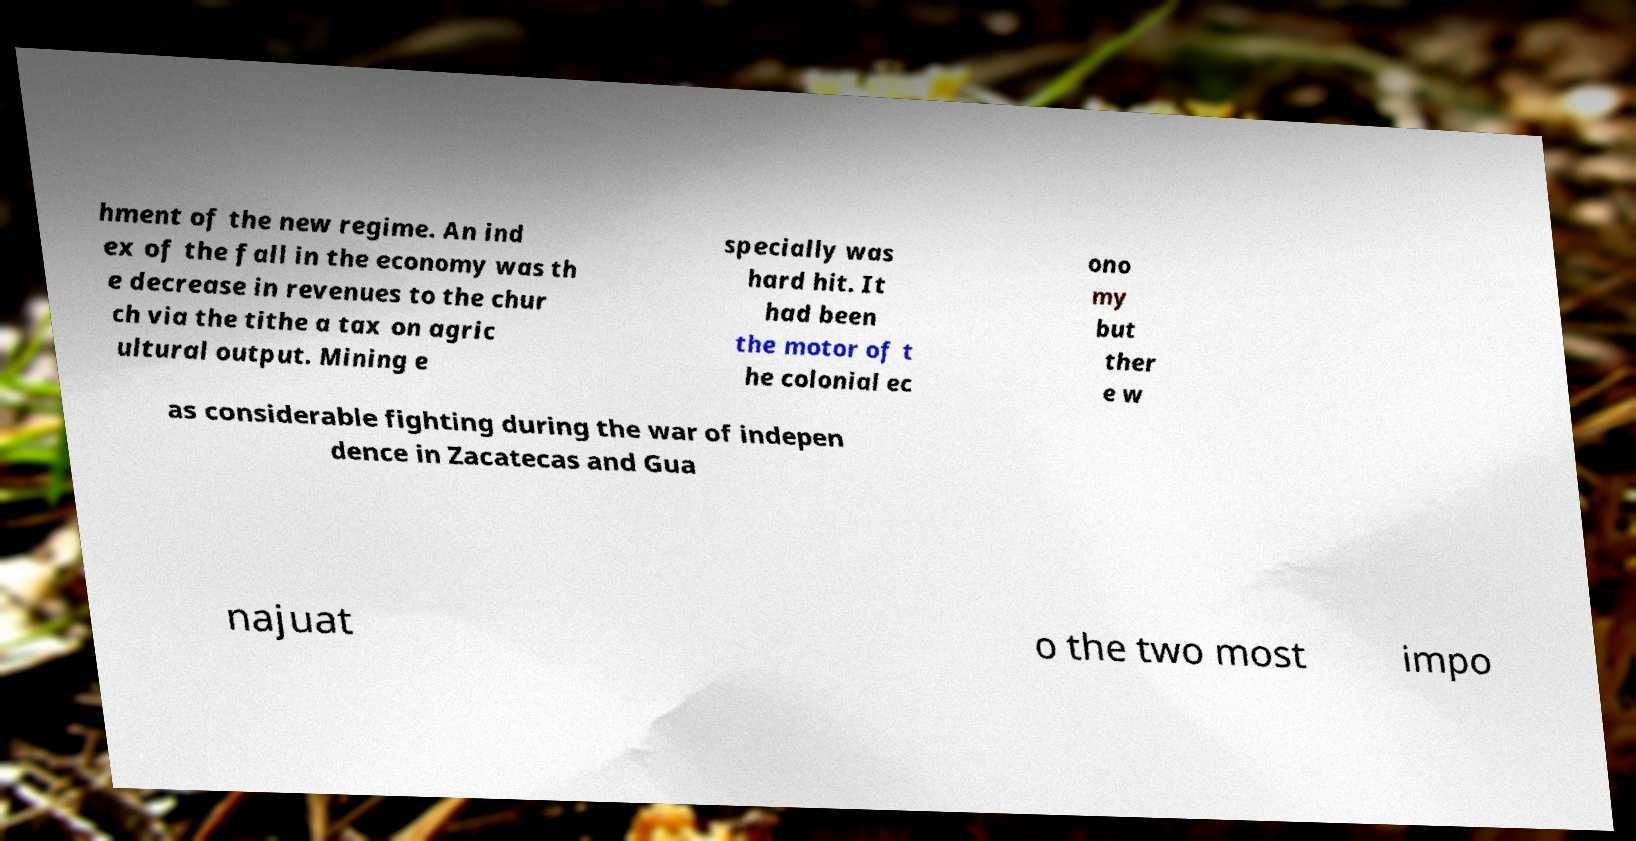For documentation purposes, I need the text within this image transcribed. Could you provide that? hment of the new regime. An ind ex of the fall in the economy was th e decrease in revenues to the chur ch via the tithe a tax on agric ultural output. Mining e specially was hard hit. It had been the motor of t he colonial ec ono my but ther e w as considerable fighting during the war of indepen dence in Zacatecas and Gua najuat o the two most impo 